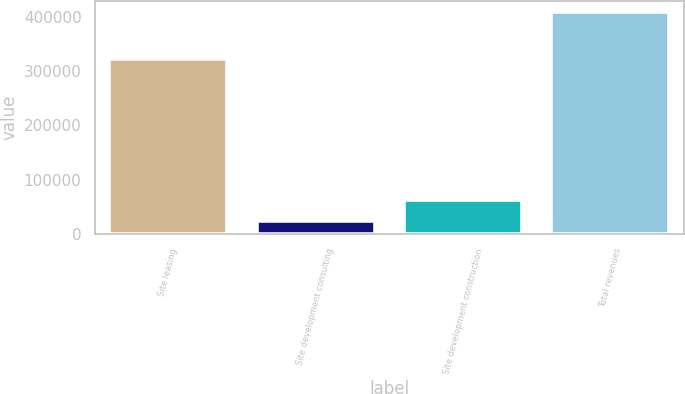Convert chart to OTSL. <chart><loc_0><loc_0><loc_500><loc_500><bar_chart><fcel>Site leasing<fcel>Site development consulting<fcel>Site development construction<fcel>Total revenues<nl><fcel>321818<fcel>24349<fcel>62734.2<fcel>408201<nl></chart> 